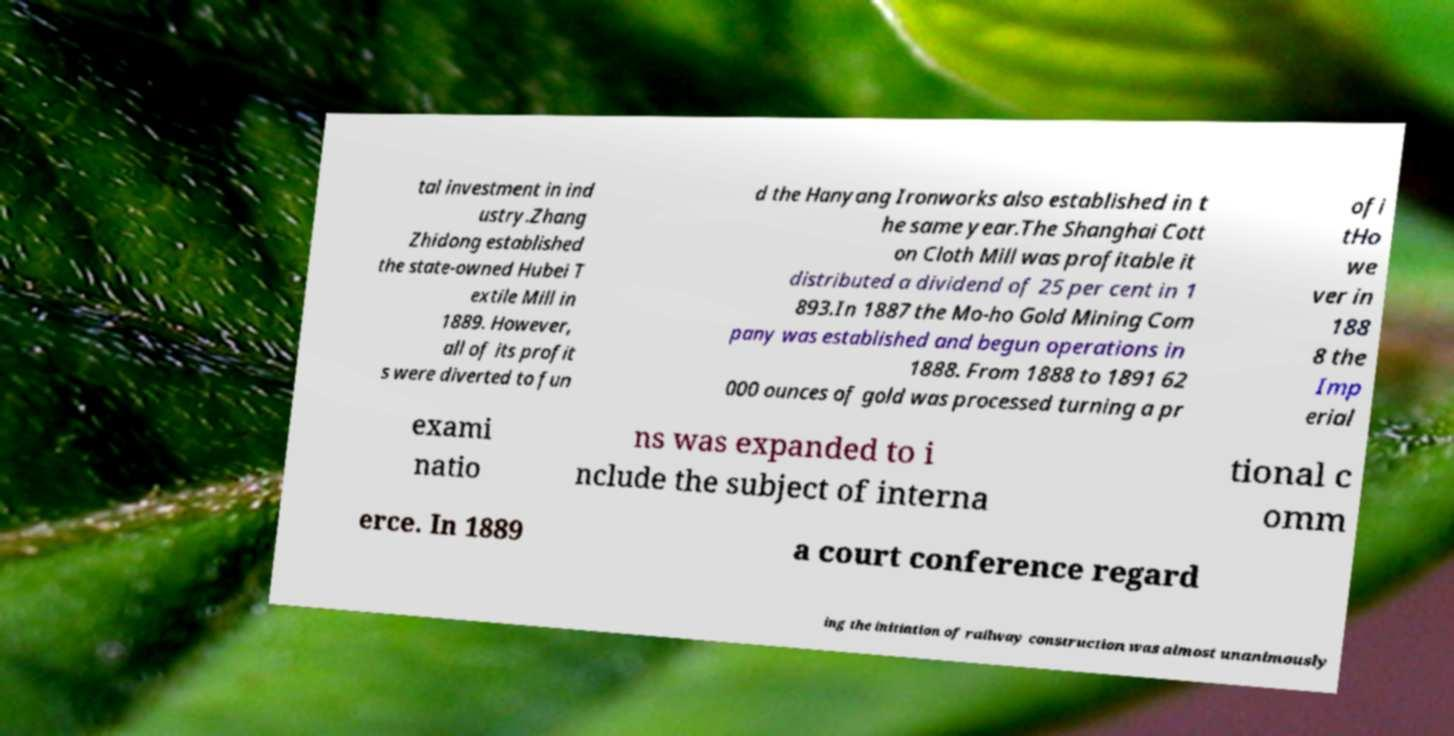For documentation purposes, I need the text within this image transcribed. Could you provide that? tal investment in ind ustry.Zhang Zhidong established the state-owned Hubei T extile Mill in 1889. However, all of its profit s were diverted to fun d the Hanyang Ironworks also established in t he same year.The Shanghai Cott on Cloth Mill was profitable it distributed a dividend of 25 per cent in 1 893.In 1887 the Mo-ho Gold Mining Com pany was established and begun operations in 1888. From 1888 to 1891 62 000 ounces of gold was processed turning a pr ofi tHo we ver in 188 8 the Imp erial exami natio ns was expanded to i nclude the subject of interna tional c omm erce. In 1889 a court conference regard ing the initiation of railway construction was almost unanimously 